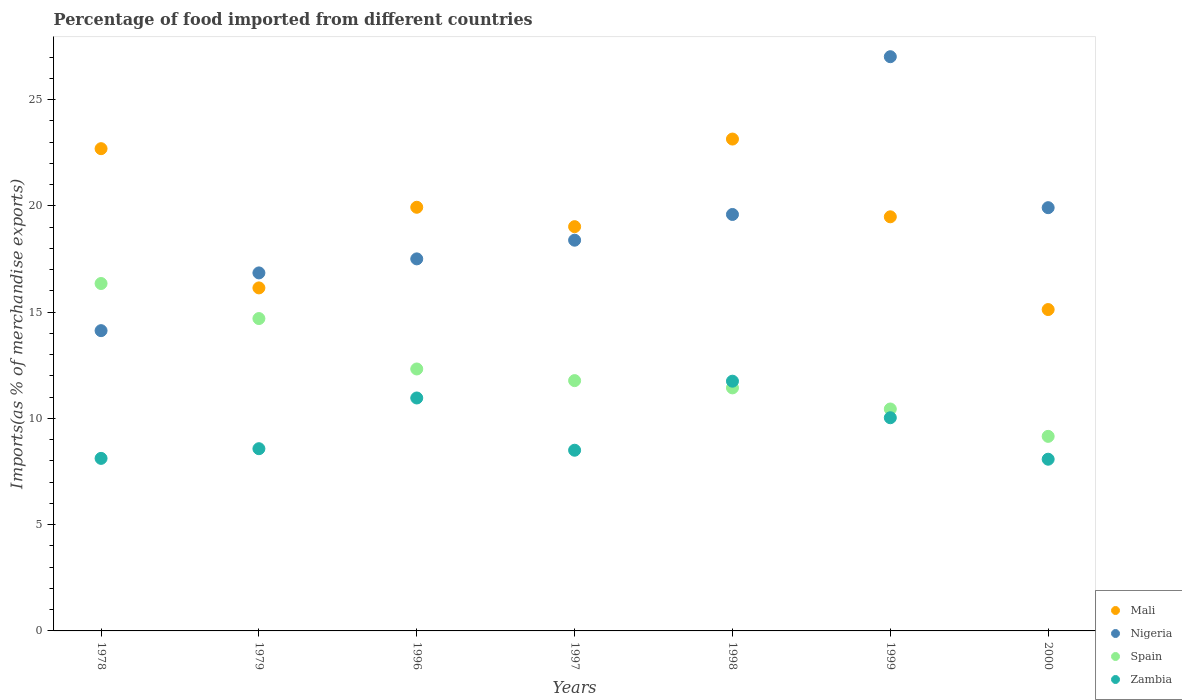How many different coloured dotlines are there?
Your answer should be very brief. 4. Is the number of dotlines equal to the number of legend labels?
Provide a succinct answer. Yes. What is the percentage of imports to different countries in Mali in 2000?
Keep it short and to the point. 15.12. Across all years, what is the maximum percentage of imports to different countries in Zambia?
Make the answer very short. 11.75. Across all years, what is the minimum percentage of imports to different countries in Nigeria?
Your answer should be very brief. 14.13. In which year was the percentage of imports to different countries in Mali maximum?
Make the answer very short. 1998. In which year was the percentage of imports to different countries in Nigeria minimum?
Your response must be concise. 1978. What is the total percentage of imports to different countries in Nigeria in the graph?
Offer a very short reply. 133.41. What is the difference between the percentage of imports to different countries in Zambia in 1979 and that in 1996?
Offer a very short reply. -2.39. What is the difference between the percentage of imports to different countries in Spain in 1979 and the percentage of imports to different countries in Mali in 1997?
Keep it short and to the point. -4.32. What is the average percentage of imports to different countries in Mali per year?
Provide a succinct answer. 19.36. In the year 1979, what is the difference between the percentage of imports to different countries in Spain and percentage of imports to different countries in Zambia?
Your answer should be compact. 6.12. In how many years, is the percentage of imports to different countries in Mali greater than 24 %?
Your response must be concise. 0. What is the ratio of the percentage of imports to different countries in Nigeria in 1996 to that in 2000?
Offer a terse response. 0.88. Is the percentage of imports to different countries in Mali in 1978 less than that in 1979?
Offer a very short reply. No. What is the difference between the highest and the second highest percentage of imports to different countries in Spain?
Ensure brevity in your answer.  1.65. What is the difference between the highest and the lowest percentage of imports to different countries in Nigeria?
Your response must be concise. 12.89. In how many years, is the percentage of imports to different countries in Zambia greater than the average percentage of imports to different countries in Zambia taken over all years?
Provide a short and direct response. 3. Is it the case that in every year, the sum of the percentage of imports to different countries in Nigeria and percentage of imports to different countries in Mali  is greater than the sum of percentage of imports to different countries in Spain and percentage of imports to different countries in Zambia?
Ensure brevity in your answer.  Yes. Is it the case that in every year, the sum of the percentage of imports to different countries in Zambia and percentage of imports to different countries in Nigeria  is greater than the percentage of imports to different countries in Mali?
Ensure brevity in your answer.  No. How many dotlines are there?
Offer a very short reply. 4. How many years are there in the graph?
Your response must be concise. 7. What is the difference between two consecutive major ticks on the Y-axis?
Your response must be concise. 5. Are the values on the major ticks of Y-axis written in scientific E-notation?
Your answer should be very brief. No. Does the graph contain any zero values?
Your answer should be very brief. No. Does the graph contain grids?
Give a very brief answer. No. Where does the legend appear in the graph?
Make the answer very short. Bottom right. How are the legend labels stacked?
Offer a terse response. Vertical. What is the title of the graph?
Provide a succinct answer. Percentage of food imported from different countries. Does "St. Kitts and Nevis" appear as one of the legend labels in the graph?
Make the answer very short. No. What is the label or title of the Y-axis?
Ensure brevity in your answer.  Imports(as % of merchandise exports). What is the Imports(as % of merchandise exports) in Mali in 1978?
Offer a terse response. 22.69. What is the Imports(as % of merchandise exports) of Nigeria in 1978?
Ensure brevity in your answer.  14.13. What is the Imports(as % of merchandise exports) of Spain in 1978?
Keep it short and to the point. 16.35. What is the Imports(as % of merchandise exports) of Zambia in 1978?
Provide a succinct answer. 8.12. What is the Imports(as % of merchandise exports) in Mali in 1979?
Offer a terse response. 16.14. What is the Imports(as % of merchandise exports) of Nigeria in 1979?
Offer a terse response. 16.85. What is the Imports(as % of merchandise exports) of Spain in 1979?
Keep it short and to the point. 14.7. What is the Imports(as % of merchandise exports) in Zambia in 1979?
Offer a terse response. 8.57. What is the Imports(as % of merchandise exports) in Mali in 1996?
Make the answer very short. 19.94. What is the Imports(as % of merchandise exports) in Nigeria in 1996?
Keep it short and to the point. 17.51. What is the Imports(as % of merchandise exports) in Spain in 1996?
Your answer should be compact. 12.33. What is the Imports(as % of merchandise exports) in Zambia in 1996?
Ensure brevity in your answer.  10.96. What is the Imports(as % of merchandise exports) in Mali in 1997?
Offer a very short reply. 19.02. What is the Imports(as % of merchandise exports) of Nigeria in 1997?
Provide a short and direct response. 18.39. What is the Imports(as % of merchandise exports) of Spain in 1997?
Your response must be concise. 11.78. What is the Imports(as % of merchandise exports) in Zambia in 1997?
Give a very brief answer. 8.5. What is the Imports(as % of merchandise exports) of Mali in 1998?
Offer a terse response. 23.15. What is the Imports(as % of merchandise exports) in Nigeria in 1998?
Offer a very short reply. 19.6. What is the Imports(as % of merchandise exports) of Spain in 1998?
Offer a very short reply. 11.44. What is the Imports(as % of merchandise exports) in Zambia in 1998?
Provide a short and direct response. 11.75. What is the Imports(as % of merchandise exports) in Mali in 1999?
Keep it short and to the point. 19.49. What is the Imports(as % of merchandise exports) in Nigeria in 1999?
Give a very brief answer. 27.02. What is the Imports(as % of merchandise exports) of Spain in 1999?
Your answer should be compact. 10.44. What is the Imports(as % of merchandise exports) in Zambia in 1999?
Make the answer very short. 10.03. What is the Imports(as % of merchandise exports) of Mali in 2000?
Your response must be concise. 15.12. What is the Imports(as % of merchandise exports) in Nigeria in 2000?
Offer a very short reply. 19.92. What is the Imports(as % of merchandise exports) in Spain in 2000?
Make the answer very short. 9.16. What is the Imports(as % of merchandise exports) of Zambia in 2000?
Provide a short and direct response. 8.08. Across all years, what is the maximum Imports(as % of merchandise exports) of Mali?
Ensure brevity in your answer.  23.15. Across all years, what is the maximum Imports(as % of merchandise exports) of Nigeria?
Give a very brief answer. 27.02. Across all years, what is the maximum Imports(as % of merchandise exports) of Spain?
Offer a terse response. 16.35. Across all years, what is the maximum Imports(as % of merchandise exports) of Zambia?
Your answer should be compact. 11.75. Across all years, what is the minimum Imports(as % of merchandise exports) in Mali?
Your response must be concise. 15.12. Across all years, what is the minimum Imports(as % of merchandise exports) in Nigeria?
Ensure brevity in your answer.  14.13. Across all years, what is the minimum Imports(as % of merchandise exports) in Spain?
Make the answer very short. 9.16. Across all years, what is the minimum Imports(as % of merchandise exports) of Zambia?
Offer a terse response. 8.08. What is the total Imports(as % of merchandise exports) of Mali in the graph?
Provide a succinct answer. 135.55. What is the total Imports(as % of merchandise exports) in Nigeria in the graph?
Your answer should be very brief. 133.41. What is the total Imports(as % of merchandise exports) in Spain in the graph?
Provide a succinct answer. 86.19. What is the total Imports(as % of merchandise exports) in Zambia in the graph?
Your response must be concise. 66.02. What is the difference between the Imports(as % of merchandise exports) of Mali in 1978 and that in 1979?
Your response must be concise. 6.55. What is the difference between the Imports(as % of merchandise exports) in Nigeria in 1978 and that in 1979?
Provide a succinct answer. -2.72. What is the difference between the Imports(as % of merchandise exports) in Spain in 1978 and that in 1979?
Ensure brevity in your answer.  1.65. What is the difference between the Imports(as % of merchandise exports) in Zambia in 1978 and that in 1979?
Ensure brevity in your answer.  -0.46. What is the difference between the Imports(as % of merchandise exports) in Mali in 1978 and that in 1996?
Offer a terse response. 2.76. What is the difference between the Imports(as % of merchandise exports) of Nigeria in 1978 and that in 1996?
Give a very brief answer. -3.38. What is the difference between the Imports(as % of merchandise exports) in Spain in 1978 and that in 1996?
Provide a short and direct response. 4.02. What is the difference between the Imports(as % of merchandise exports) of Zambia in 1978 and that in 1996?
Give a very brief answer. -2.84. What is the difference between the Imports(as % of merchandise exports) of Mali in 1978 and that in 1997?
Your answer should be very brief. 3.67. What is the difference between the Imports(as % of merchandise exports) in Nigeria in 1978 and that in 1997?
Provide a succinct answer. -4.26. What is the difference between the Imports(as % of merchandise exports) in Spain in 1978 and that in 1997?
Your answer should be very brief. 4.57. What is the difference between the Imports(as % of merchandise exports) of Zambia in 1978 and that in 1997?
Give a very brief answer. -0.38. What is the difference between the Imports(as % of merchandise exports) in Mali in 1978 and that in 1998?
Provide a succinct answer. -0.45. What is the difference between the Imports(as % of merchandise exports) in Nigeria in 1978 and that in 1998?
Ensure brevity in your answer.  -5.47. What is the difference between the Imports(as % of merchandise exports) in Spain in 1978 and that in 1998?
Provide a succinct answer. 4.91. What is the difference between the Imports(as % of merchandise exports) in Zambia in 1978 and that in 1998?
Provide a short and direct response. -3.63. What is the difference between the Imports(as % of merchandise exports) in Mali in 1978 and that in 1999?
Provide a short and direct response. 3.21. What is the difference between the Imports(as % of merchandise exports) of Nigeria in 1978 and that in 1999?
Your response must be concise. -12.89. What is the difference between the Imports(as % of merchandise exports) in Spain in 1978 and that in 1999?
Provide a short and direct response. 5.91. What is the difference between the Imports(as % of merchandise exports) in Zambia in 1978 and that in 1999?
Your response must be concise. -1.91. What is the difference between the Imports(as % of merchandise exports) of Mali in 1978 and that in 2000?
Give a very brief answer. 7.57. What is the difference between the Imports(as % of merchandise exports) in Nigeria in 1978 and that in 2000?
Keep it short and to the point. -5.79. What is the difference between the Imports(as % of merchandise exports) of Spain in 1978 and that in 2000?
Provide a short and direct response. 7.19. What is the difference between the Imports(as % of merchandise exports) in Zambia in 1978 and that in 2000?
Keep it short and to the point. 0.04. What is the difference between the Imports(as % of merchandise exports) of Mali in 1979 and that in 1996?
Your response must be concise. -3.79. What is the difference between the Imports(as % of merchandise exports) of Nigeria in 1979 and that in 1996?
Your answer should be compact. -0.66. What is the difference between the Imports(as % of merchandise exports) of Spain in 1979 and that in 1996?
Your answer should be compact. 2.37. What is the difference between the Imports(as % of merchandise exports) in Zambia in 1979 and that in 1996?
Ensure brevity in your answer.  -2.39. What is the difference between the Imports(as % of merchandise exports) of Mali in 1979 and that in 1997?
Provide a short and direct response. -2.88. What is the difference between the Imports(as % of merchandise exports) in Nigeria in 1979 and that in 1997?
Offer a terse response. -1.54. What is the difference between the Imports(as % of merchandise exports) of Spain in 1979 and that in 1997?
Your answer should be compact. 2.92. What is the difference between the Imports(as % of merchandise exports) of Zambia in 1979 and that in 1997?
Your response must be concise. 0.07. What is the difference between the Imports(as % of merchandise exports) in Mali in 1979 and that in 1998?
Provide a short and direct response. -7. What is the difference between the Imports(as % of merchandise exports) in Nigeria in 1979 and that in 1998?
Your answer should be compact. -2.75. What is the difference between the Imports(as % of merchandise exports) in Spain in 1979 and that in 1998?
Your response must be concise. 3.26. What is the difference between the Imports(as % of merchandise exports) in Zambia in 1979 and that in 1998?
Provide a short and direct response. -3.18. What is the difference between the Imports(as % of merchandise exports) of Mali in 1979 and that in 1999?
Offer a terse response. -3.35. What is the difference between the Imports(as % of merchandise exports) of Nigeria in 1979 and that in 1999?
Keep it short and to the point. -10.17. What is the difference between the Imports(as % of merchandise exports) of Spain in 1979 and that in 1999?
Give a very brief answer. 4.26. What is the difference between the Imports(as % of merchandise exports) of Zambia in 1979 and that in 1999?
Your answer should be compact. -1.46. What is the difference between the Imports(as % of merchandise exports) of Mali in 1979 and that in 2000?
Give a very brief answer. 1.02. What is the difference between the Imports(as % of merchandise exports) in Nigeria in 1979 and that in 2000?
Keep it short and to the point. -3.07. What is the difference between the Imports(as % of merchandise exports) in Spain in 1979 and that in 2000?
Provide a short and direct response. 5.54. What is the difference between the Imports(as % of merchandise exports) in Zambia in 1979 and that in 2000?
Make the answer very short. 0.49. What is the difference between the Imports(as % of merchandise exports) in Mali in 1996 and that in 1997?
Make the answer very short. 0.91. What is the difference between the Imports(as % of merchandise exports) of Nigeria in 1996 and that in 1997?
Your response must be concise. -0.88. What is the difference between the Imports(as % of merchandise exports) of Spain in 1996 and that in 1997?
Your answer should be compact. 0.55. What is the difference between the Imports(as % of merchandise exports) in Zambia in 1996 and that in 1997?
Make the answer very short. 2.46. What is the difference between the Imports(as % of merchandise exports) of Mali in 1996 and that in 1998?
Keep it short and to the point. -3.21. What is the difference between the Imports(as % of merchandise exports) of Nigeria in 1996 and that in 1998?
Give a very brief answer. -2.09. What is the difference between the Imports(as % of merchandise exports) in Spain in 1996 and that in 1998?
Your response must be concise. 0.89. What is the difference between the Imports(as % of merchandise exports) in Zambia in 1996 and that in 1998?
Give a very brief answer. -0.79. What is the difference between the Imports(as % of merchandise exports) in Mali in 1996 and that in 1999?
Your answer should be very brief. 0.45. What is the difference between the Imports(as % of merchandise exports) of Nigeria in 1996 and that in 1999?
Offer a very short reply. -9.51. What is the difference between the Imports(as % of merchandise exports) in Spain in 1996 and that in 1999?
Offer a terse response. 1.88. What is the difference between the Imports(as % of merchandise exports) in Zambia in 1996 and that in 1999?
Keep it short and to the point. 0.93. What is the difference between the Imports(as % of merchandise exports) in Mali in 1996 and that in 2000?
Provide a short and direct response. 4.81. What is the difference between the Imports(as % of merchandise exports) in Nigeria in 1996 and that in 2000?
Give a very brief answer. -2.41. What is the difference between the Imports(as % of merchandise exports) in Spain in 1996 and that in 2000?
Your answer should be very brief. 3.17. What is the difference between the Imports(as % of merchandise exports) of Zambia in 1996 and that in 2000?
Give a very brief answer. 2.88. What is the difference between the Imports(as % of merchandise exports) in Mali in 1997 and that in 1998?
Ensure brevity in your answer.  -4.12. What is the difference between the Imports(as % of merchandise exports) of Nigeria in 1997 and that in 1998?
Your answer should be compact. -1.21. What is the difference between the Imports(as % of merchandise exports) in Spain in 1997 and that in 1998?
Offer a terse response. 0.34. What is the difference between the Imports(as % of merchandise exports) in Zambia in 1997 and that in 1998?
Ensure brevity in your answer.  -3.25. What is the difference between the Imports(as % of merchandise exports) of Mali in 1997 and that in 1999?
Ensure brevity in your answer.  -0.46. What is the difference between the Imports(as % of merchandise exports) in Nigeria in 1997 and that in 1999?
Provide a short and direct response. -8.63. What is the difference between the Imports(as % of merchandise exports) of Spain in 1997 and that in 1999?
Provide a succinct answer. 1.34. What is the difference between the Imports(as % of merchandise exports) of Zambia in 1997 and that in 1999?
Keep it short and to the point. -1.53. What is the difference between the Imports(as % of merchandise exports) of Mali in 1997 and that in 2000?
Your answer should be compact. 3.9. What is the difference between the Imports(as % of merchandise exports) in Nigeria in 1997 and that in 2000?
Provide a succinct answer. -1.53. What is the difference between the Imports(as % of merchandise exports) in Spain in 1997 and that in 2000?
Give a very brief answer. 2.62. What is the difference between the Imports(as % of merchandise exports) in Zambia in 1997 and that in 2000?
Offer a very short reply. 0.42. What is the difference between the Imports(as % of merchandise exports) of Mali in 1998 and that in 1999?
Offer a very short reply. 3.66. What is the difference between the Imports(as % of merchandise exports) in Nigeria in 1998 and that in 1999?
Make the answer very short. -7.42. What is the difference between the Imports(as % of merchandise exports) in Zambia in 1998 and that in 1999?
Offer a terse response. 1.72. What is the difference between the Imports(as % of merchandise exports) in Mali in 1998 and that in 2000?
Your response must be concise. 8.02. What is the difference between the Imports(as % of merchandise exports) in Nigeria in 1998 and that in 2000?
Give a very brief answer. -0.32. What is the difference between the Imports(as % of merchandise exports) in Spain in 1998 and that in 2000?
Offer a very short reply. 2.28. What is the difference between the Imports(as % of merchandise exports) in Zambia in 1998 and that in 2000?
Make the answer very short. 3.67. What is the difference between the Imports(as % of merchandise exports) of Mali in 1999 and that in 2000?
Give a very brief answer. 4.36. What is the difference between the Imports(as % of merchandise exports) of Nigeria in 1999 and that in 2000?
Provide a short and direct response. 7.1. What is the difference between the Imports(as % of merchandise exports) of Spain in 1999 and that in 2000?
Offer a terse response. 1.29. What is the difference between the Imports(as % of merchandise exports) in Zambia in 1999 and that in 2000?
Offer a very short reply. 1.95. What is the difference between the Imports(as % of merchandise exports) in Mali in 1978 and the Imports(as % of merchandise exports) in Nigeria in 1979?
Your response must be concise. 5.85. What is the difference between the Imports(as % of merchandise exports) in Mali in 1978 and the Imports(as % of merchandise exports) in Spain in 1979?
Keep it short and to the point. 7.99. What is the difference between the Imports(as % of merchandise exports) in Mali in 1978 and the Imports(as % of merchandise exports) in Zambia in 1979?
Make the answer very short. 14.12. What is the difference between the Imports(as % of merchandise exports) in Nigeria in 1978 and the Imports(as % of merchandise exports) in Spain in 1979?
Offer a very short reply. -0.57. What is the difference between the Imports(as % of merchandise exports) of Nigeria in 1978 and the Imports(as % of merchandise exports) of Zambia in 1979?
Your answer should be compact. 5.55. What is the difference between the Imports(as % of merchandise exports) of Spain in 1978 and the Imports(as % of merchandise exports) of Zambia in 1979?
Your answer should be compact. 7.77. What is the difference between the Imports(as % of merchandise exports) of Mali in 1978 and the Imports(as % of merchandise exports) of Nigeria in 1996?
Give a very brief answer. 5.19. What is the difference between the Imports(as % of merchandise exports) of Mali in 1978 and the Imports(as % of merchandise exports) of Spain in 1996?
Provide a succinct answer. 10.37. What is the difference between the Imports(as % of merchandise exports) of Mali in 1978 and the Imports(as % of merchandise exports) of Zambia in 1996?
Provide a succinct answer. 11.73. What is the difference between the Imports(as % of merchandise exports) in Nigeria in 1978 and the Imports(as % of merchandise exports) in Spain in 1996?
Give a very brief answer. 1.8. What is the difference between the Imports(as % of merchandise exports) in Nigeria in 1978 and the Imports(as % of merchandise exports) in Zambia in 1996?
Make the answer very short. 3.17. What is the difference between the Imports(as % of merchandise exports) of Spain in 1978 and the Imports(as % of merchandise exports) of Zambia in 1996?
Offer a terse response. 5.39. What is the difference between the Imports(as % of merchandise exports) of Mali in 1978 and the Imports(as % of merchandise exports) of Nigeria in 1997?
Your answer should be very brief. 4.31. What is the difference between the Imports(as % of merchandise exports) of Mali in 1978 and the Imports(as % of merchandise exports) of Spain in 1997?
Your answer should be compact. 10.91. What is the difference between the Imports(as % of merchandise exports) in Mali in 1978 and the Imports(as % of merchandise exports) in Zambia in 1997?
Your response must be concise. 14.19. What is the difference between the Imports(as % of merchandise exports) in Nigeria in 1978 and the Imports(as % of merchandise exports) in Spain in 1997?
Offer a very short reply. 2.35. What is the difference between the Imports(as % of merchandise exports) in Nigeria in 1978 and the Imports(as % of merchandise exports) in Zambia in 1997?
Provide a short and direct response. 5.63. What is the difference between the Imports(as % of merchandise exports) of Spain in 1978 and the Imports(as % of merchandise exports) of Zambia in 1997?
Make the answer very short. 7.85. What is the difference between the Imports(as % of merchandise exports) of Mali in 1978 and the Imports(as % of merchandise exports) of Nigeria in 1998?
Your response must be concise. 3.1. What is the difference between the Imports(as % of merchandise exports) in Mali in 1978 and the Imports(as % of merchandise exports) in Spain in 1998?
Your response must be concise. 11.26. What is the difference between the Imports(as % of merchandise exports) in Mali in 1978 and the Imports(as % of merchandise exports) in Zambia in 1998?
Offer a terse response. 10.94. What is the difference between the Imports(as % of merchandise exports) in Nigeria in 1978 and the Imports(as % of merchandise exports) in Spain in 1998?
Your answer should be compact. 2.69. What is the difference between the Imports(as % of merchandise exports) of Nigeria in 1978 and the Imports(as % of merchandise exports) of Zambia in 1998?
Make the answer very short. 2.38. What is the difference between the Imports(as % of merchandise exports) of Spain in 1978 and the Imports(as % of merchandise exports) of Zambia in 1998?
Provide a short and direct response. 4.6. What is the difference between the Imports(as % of merchandise exports) in Mali in 1978 and the Imports(as % of merchandise exports) in Nigeria in 1999?
Make the answer very short. -4.33. What is the difference between the Imports(as % of merchandise exports) in Mali in 1978 and the Imports(as % of merchandise exports) in Spain in 1999?
Keep it short and to the point. 12.25. What is the difference between the Imports(as % of merchandise exports) of Mali in 1978 and the Imports(as % of merchandise exports) of Zambia in 1999?
Make the answer very short. 12.66. What is the difference between the Imports(as % of merchandise exports) of Nigeria in 1978 and the Imports(as % of merchandise exports) of Spain in 1999?
Your answer should be compact. 3.69. What is the difference between the Imports(as % of merchandise exports) in Nigeria in 1978 and the Imports(as % of merchandise exports) in Zambia in 1999?
Keep it short and to the point. 4.1. What is the difference between the Imports(as % of merchandise exports) in Spain in 1978 and the Imports(as % of merchandise exports) in Zambia in 1999?
Provide a succinct answer. 6.32. What is the difference between the Imports(as % of merchandise exports) of Mali in 1978 and the Imports(as % of merchandise exports) of Nigeria in 2000?
Keep it short and to the point. 2.78. What is the difference between the Imports(as % of merchandise exports) of Mali in 1978 and the Imports(as % of merchandise exports) of Spain in 2000?
Your answer should be compact. 13.54. What is the difference between the Imports(as % of merchandise exports) in Mali in 1978 and the Imports(as % of merchandise exports) in Zambia in 2000?
Your answer should be compact. 14.61. What is the difference between the Imports(as % of merchandise exports) in Nigeria in 1978 and the Imports(as % of merchandise exports) in Spain in 2000?
Provide a succinct answer. 4.97. What is the difference between the Imports(as % of merchandise exports) in Nigeria in 1978 and the Imports(as % of merchandise exports) in Zambia in 2000?
Keep it short and to the point. 6.05. What is the difference between the Imports(as % of merchandise exports) in Spain in 1978 and the Imports(as % of merchandise exports) in Zambia in 2000?
Keep it short and to the point. 8.27. What is the difference between the Imports(as % of merchandise exports) in Mali in 1979 and the Imports(as % of merchandise exports) in Nigeria in 1996?
Keep it short and to the point. -1.37. What is the difference between the Imports(as % of merchandise exports) of Mali in 1979 and the Imports(as % of merchandise exports) of Spain in 1996?
Provide a short and direct response. 3.82. What is the difference between the Imports(as % of merchandise exports) in Mali in 1979 and the Imports(as % of merchandise exports) in Zambia in 1996?
Offer a very short reply. 5.18. What is the difference between the Imports(as % of merchandise exports) in Nigeria in 1979 and the Imports(as % of merchandise exports) in Spain in 1996?
Keep it short and to the point. 4.52. What is the difference between the Imports(as % of merchandise exports) in Nigeria in 1979 and the Imports(as % of merchandise exports) in Zambia in 1996?
Provide a succinct answer. 5.89. What is the difference between the Imports(as % of merchandise exports) of Spain in 1979 and the Imports(as % of merchandise exports) of Zambia in 1996?
Your answer should be compact. 3.74. What is the difference between the Imports(as % of merchandise exports) in Mali in 1979 and the Imports(as % of merchandise exports) in Nigeria in 1997?
Ensure brevity in your answer.  -2.25. What is the difference between the Imports(as % of merchandise exports) in Mali in 1979 and the Imports(as % of merchandise exports) in Spain in 1997?
Provide a short and direct response. 4.36. What is the difference between the Imports(as % of merchandise exports) of Mali in 1979 and the Imports(as % of merchandise exports) of Zambia in 1997?
Your response must be concise. 7.64. What is the difference between the Imports(as % of merchandise exports) of Nigeria in 1979 and the Imports(as % of merchandise exports) of Spain in 1997?
Make the answer very short. 5.07. What is the difference between the Imports(as % of merchandise exports) in Nigeria in 1979 and the Imports(as % of merchandise exports) in Zambia in 1997?
Provide a succinct answer. 8.34. What is the difference between the Imports(as % of merchandise exports) of Spain in 1979 and the Imports(as % of merchandise exports) of Zambia in 1997?
Offer a very short reply. 6.2. What is the difference between the Imports(as % of merchandise exports) in Mali in 1979 and the Imports(as % of merchandise exports) in Nigeria in 1998?
Your answer should be compact. -3.46. What is the difference between the Imports(as % of merchandise exports) of Mali in 1979 and the Imports(as % of merchandise exports) of Spain in 1998?
Give a very brief answer. 4.7. What is the difference between the Imports(as % of merchandise exports) of Mali in 1979 and the Imports(as % of merchandise exports) of Zambia in 1998?
Give a very brief answer. 4.39. What is the difference between the Imports(as % of merchandise exports) of Nigeria in 1979 and the Imports(as % of merchandise exports) of Spain in 1998?
Offer a terse response. 5.41. What is the difference between the Imports(as % of merchandise exports) in Nigeria in 1979 and the Imports(as % of merchandise exports) in Zambia in 1998?
Offer a terse response. 5.1. What is the difference between the Imports(as % of merchandise exports) in Spain in 1979 and the Imports(as % of merchandise exports) in Zambia in 1998?
Keep it short and to the point. 2.95. What is the difference between the Imports(as % of merchandise exports) of Mali in 1979 and the Imports(as % of merchandise exports) of Nigeria in 1999?
Provide a short and direct response. -10.88. What is the difference between the Imports(as % of merchandise exports) of Mali in 1979 and the Imports(as % of merchandise exports) of Spain in 1999?
Your answer should be very brief. 5.7. What is the difference between the Imports(as % of merchandise exports) in Mali in 1979 and the Imports(as % of merchandise exports) in Zambia in 1999?
Your answer should be very brief. 6.11. What is the difference between the Imports(as % of merchandise exports) in Nigeria in 1979 and the Imports(as % of merchandise exports) in Spain in 1999?
Provide a short and direct response. 6.4. What is the difference between the Imports(as % of merchandise exports) of Nigeria in 1979 and the Imports(as % of merchandise exports) of Zambia in 1999?
Offer a terse response. 6.82. What is the difference between the Imports(as % of merchandise exports) in Spain in 1979 and the Imports(as % of merchandise exports) in Zambia in 1999?
Provide a short and direct response. 4.67. What is the difference between the Imports(as % of merchandise exports) of Mali in 1979 and the Imports(as % of merchandise exports) of Nigeria in 2000?
Offer a very short reply. -3.78. What is the difference between the Imports(as % of merchandise exports) of Mali in 1979 and the Imports(as % of merchandise exports) of Spain in 2000?
Offer a terse response. 6.99. What is the difference between the Imports(as % of merchandise exports) of Mali in 1979 and the Imports(as % of merchandise exports) of Zambia in 2000?
Your answer should be very brief. 8.06. What is the difference between the Imports(as % of merchandise exports) of Nigeria in 1979 and the Imports(as % of merchandise exports) of Spain in 2000?
Provide a short and direct response. 7.69. What is the difference between the Imports(as % of merchandise exports) in Nigeria in 1979 and the Imports(as % of merchandise exports) in Zambia in 2000?
Ensure brevity in your answer.  8.77. What is the difference between the Imports(as % of merchandise exports) of Spain in 1979 and the Imports(as % of merchandise exports) of Zambia in 2000?
Provide a succinct answer. 6.62. What is the difference between the Imports(as % of merchandise exports) of Mali in 1996 and the Imports(as % of merchandise exports) of Nigeria in 1997?
Give a very brief answer. 1.55. What is the difference between the Imports(as % of merchandise exports) of Mali in 1996 and the Imports(as % of merchandise exports) of Spain in 1997?
Offer a terse response. 8.16. What is the difference between the Imports(as % of merchandise exports) in Mali in 1996 and the Imports(as % of merchandise exports) in Zambia in 1997?
Your response must be concise. 11.43. What is the difference between the Imports(as % of merchandise exports) in Nigeria in 1996 and the Imports(as % of merchandise exports) in Spain in 1997?
Your answer should be compact. 5.73. What is the difference between the Imports(as % of merchandise exports) of Nigeria in 1996 and the Imports(as % of merchandise exports) of Zambia in 1997?
Provide a succinct answer. 9. What is the difference between the Imports(as % of merchandise exports) of Spain in 1996 and the Imports(as % of merchandise exports) of Zambia in 1997?
Your response must be concise. 3.82. What is the difference between the Imports(as % of merchandise exports) of Mali in 1996 and the Imports(as % of merchandise exports) of Nigeria in 1998?
Ensure brevity in your answer.  0.34. What is the difference between the Imports(as % of merchandise exports) of Mali in 1996 and the Imports(as % of merchandise exports) of Spain in 1998?
Your answer should be very brief. 8.5. What is the difference between the Imports(as % of merchandise exports) of Mali in 1996 and the Imports(as % of merchandise exports) of Zambia in 1998?
Provide a succinct answer. 8.18. What is the difference between the Imports(as % of merchandise exports) of Nigeria in 1996 and the Imports(as % of merchandise exports) of Spain in 1998?
Provide a short and direct response. 6.07. What is the difference between the Imports(as % of merchandise exports) of Nigeria in 1996 and the Imports(as % of merchandise exports) of Zambia in 1998?
Your answer should be compact. 5.76. What is the difference between the Imports(as % of merchandise exports) in Spain in 1996 and the Imports(as % of merchandise exports) in Zambia in 1998?
Give a very brief answer. 0.57. What is the difference between the Imports(as % of merchandise exports) in Mali in 1996 and the Imports(as % of merchandise exports) in Nigeria in 1999?
Make the answer very short. -7.09. What is the difference between the Imports(as % of merchandise exports) in Mali in 1996 and the Imports(as % of merchandise exports) in Spain in 1999?
Offer a terse response. 9.49. What is the difference between the Imports(as % of merchandise exports) in Mali in 1996 and the Imports(as % of merchandise exports) in Zambia in 1999?
Your response must be concise. 9.9. What is the difference between the Imports(as % of merchandise exports) of Nigeria in 1996 and the Imports(as % of merchandise exports) of Spain in 1999?
Give a very brief answer. 7.06. What is the difference between the Imports(as % of merchandise exports) in Nigeria in 1996 and the Imports(as % of merchandise exports) in Zambia in 1999?
Your response must be concise. 7.48. What is the difference between the Imports(as % of merchandise exports) in Spain in 1996 and the Imports(as % of merchandise exports) in Zambia in 1999?
Offer a terse response. 2.29. What is the difference between the Imports(as % of merchandise exports) in Mali in 1996 and the Imports(as % of merchandise exports) in Nigeria in 2000?
Offer a terse response. 0.02. What is the difference between the Imports(as % of merchandise exports) of Mali in 1996 and the Imports(as % of merchandise exports) of Spain in 2000?
Ensure brevity in your answer.  10.78. What is the difference between the Imports(as % of merchandise exports) of Mali in 1996 and the Imports(as % of merchandise exports) of Zambia in 2000?
Your answer should be compact. 11.86. What is the difference between the Imports(as % of merchandise exports) of Nigeria in 1996 and the Imports(as % of merchandise exports) of Spain in 2000?
Keep it short and to the point. 8.35. What is the difference between the Imports(as % of merchandise exports) in Nigeria in 1996 and the Imports(as % of merchandise exports) in Zambia in 2000?
Your answer should be very brief. 9.43. What is the difference between the Imports(as % of merchandise exports) of Spain in 1996 and the Imports(as % of merchandise exports) of Zambia in 2000?
Your response must be concise. 4.25. What is the difference between the Imports(as % of merchandise exports) in Mali in 1997 and the Imports(as % of merchandise exports) in Nigeria in 1998?
Make the answer very short. -0.57. What is the difference between the Imports(as % of merchandise exports) in Mali in 1997 and the Imports(as % of merchandise exports) in Spain in 1998?
Provide a succinct answer. 7.59. What is the difference between the Imports(as % of merchandise exports) in Mali in 1997 and the Imports(as % of merchandise exports) in Zambia in 1998?
Make the answer very short. 7.27. What is the difference between the Imports(as % of merchandise exports) of Nigeria in 1997 and the Imports(as % of merchandise exports) of Spain in 1998?
Make the answer very short. 6.95. What is the difference between the Imports(as % of merchandise exports) of Nigeria in 1997 and the Imports(as % of merchandise exports) of Zambia in 1998?
Make the answer very short. 6.63. What is the difference between the Imports(as % of merchandise exports) of Spain in 1997 and the Imports(as % of merchandise exports) of Zambia in 1998?
Your response must be concise. 0.03. What is the difference between the Imports(as % of merchandise exports) in Mali in 1997 and the Imports(as % of merchandise exports) in Nigeria in 1999?
Ensure brevity in your answer.  -8. What is the difference between the Imports(as % of merchandise exports) in Mali in 1997 and the Imports(as % of merchandise exports) in Spain in 1999?
Ensure brevity in your answer.  8.58. What is the difference between the Imports(as % of merchandise exports) of Mali in 1997 and the Imports(as % of merchandise exports) of Zambia in 1999?
Your answer should be very brief. 8.99. What is the difference between the Imports(as % of merchandise exports) of Nigeria in 1997 and the Imports(as % of merchandise exports) of Spain in 1999?
Your response must be concise. 7.94. What is the difference between the Imports(as % of merchandise exports) in Nigeria in 1997 and the Imports(as % of merchandise exports) in Zambia in 1999?
Make the answer very short. 8.35. What is the difference between the Imports(as % of merchandise exports) in Spain in 1997 and the Imports(as % of merchandise exports) in Zambia in 1999?
Provide a succinct answer. 1.75. What is the difference between the Imports(as % of merchandise exports) of Mali in 1997 and the Imports(as % of merchandise exports) of Nigeria in 2000?
Offer a very short reply. -0.89. What is the difference between the Imports(as % of merchandise exports) of Mali in 1997 and the Imports(as % of merchandise exports) of Spain in 2000?
Your answer should be very brief. 9.87. What is the difference between the Imports(as % of merchandise exports) of Mali in 1997 and the Imports(as % of merchandise exports) of Zambia in 2000?
Provide a succinct answer. 10.94. What is the difference between the Imports(as % of merchandise exports) in Nigeria in 1997 and the Imports(as % of merchandise exports) in Spain in 2000?
Ensure brevity in your answer.  9.23. What is the difference between the Imports(as % of merchandise exports) in Nigeria in 1997 and the Imports(as % of merchandise exports) in Zambia in 2000?
Your response must be concise. 10.31. What is the difference between the Imports(as % of merchandise exports) of Spain in 1997 and the Imports(as % of merchandise exports) of Zambia in 2000?
Make the answer very short. 3.7. What is the difference between the Imports(as % of merchandise exports) in Mali in 1998 and the Imports(as % of merchandise exports) in Nigeria in 1999?
Your answer should be compact. -3.88. What is the difference between the Imports(as % of merchandise exports) in Mali in 1998 and the Imports(as % of merchandise exports) in Spain in 1999?
Provide a short and direct response. 12.7. What is the difference between the Imports(as % of merchandise exports) in Mali in 1998 and the Imports(as % of merchandise exports) in Zambia in 1999?
Offer a terse response. 13.11. What is the difference between the Imports(as % of merchandise exports) in Nigeria in 1998 and the Imports(as % of merchandise exports) in Spain in 1999?
Provide a succinct answer. 9.15. What is the difference between the Imports(as % of merchandise exports) of Nigeria in 1998 and the Imports(as % of merchandise exports) of Zambia in 1999?
Your response must be concise. 9.57. What is the difference between the Imports(as % of merchandise exports) in Spain in 1998 and the Imports(as % of merchandise exports) in Zambia in 1999?
Provide a short and direct response. 1.4. What is the difference between the Imports(as % of merchandise exports) in Mali in 1998 and the Imports(as % of merchandise exports) in Nigeria in 2000?
Provide a succinct answer. 3.23. What is the difference between the Imports(as % of merchandise exports) of Mali in 1998 and the Imports(as % of merchandise exports) of Spain in 2000?
Your answer should be very brief. 13.99. What is the difference between the Imports(as % of merchandise exports) in Mali in 1998 and the Imports(as % of merchandise exports) in Zambia in 2000?
Ensure brevity in your answer.  15.07. What is the difference between the Imports(as % of merchandise exports) in Nigeria in 1998 and the Imports(as % of merchandise exports) in Spain in 2000?
Offer a very short reply. 10.44. What is the difference between the Imports(as % of merchandise exports) in Nigeria in 1998 and the Imports(as % of merchandise exports) in Zambia in 2000?
Keep it short and to the point. 11.52. What is the difference between the Imports(as % of merchandise exports) in Spain in 1998 and the Imports(as % of merchandise exports) in Zambia in 2000?
Provide a succinct answer. 3.36. What is the difference between the Imports(as % of merchandise exports) of Mali in 1999 and the Imports(as % of merchandise exports) of Nigeria in 2000?
Your answer should be very brief. -0.43. What is the difference between the Imports(as % of merchandise exports) of Mali in 1999 and the Imports(as % of merchandise exports) of Spain in 2000?
Offer a terse response. 10.33. What is the difference between the Imports(as % of merchandise exports) of Mali in 1999 and the Imports(as % of merchandise exports) of Zambia in 2000?
Your response must be concise. 11.41. What is the difference between the Imports(as % of merchandise exports) of Nigeria in 1999 and the Imports(as % of merchandise exports) of Spain in 2000?
Your response must be concise. 17.87. What is the difference between the Imports(as % of merchandise exports) of Nigeria in 1999 and the Imports(as % of merchandise exports) of Zambia in 2000?
Provide a short and direct response. 18.94. What is the difference between the Imports(as % of merchandise exports) in Spain in 1999 and the Imports(as % of merchandise exports) in Zambia in 2000?
Provide a succinct answer. 2.36. What is the average Imports(as % of merchandise exports) of Mali per year?
Your response must be concise. 19.36. What is the average Imports(as % of merchandise exports) of Nigeria per year?
Your response must be concise. 19.06. What is the average Imports(as % of merchandise exports) in Spain per year?
Give a very brief answer. 12.31. What is the average Imports(as % of merchandise exports) of Zambia per year?
Give a very brief answer. 9.43. In the year 1978, what is the difference between the Imports(as % of merchandise exports) of Mali and Imports(as % of merchandise exports) of Nigeria?
Offer a terse response. 8.56. In the year 1978, what is the difference between the Imports(as % of merchandise exports) of Mali and Imports(as % of merchandise exports) of Spain?
Make the answer very short. 6.34. In the year 1978, what is the difference between the Imports(as % of merchandise exports) in Mali and Imports(as % of merchandise exports) in Zambia?
Keep it short and to the point. 14.57. In the year 1978, what is the difference between the Imports(as % of merchandise exports) in Nigeria and Imports(as % of merchandise exports) in Spain?
Offer a very short reply. -2.22. In the year 1978, what is the difference between the Imports(as % of merchandise exports) in Nigeria and Imports(as % of merchandise exports) in Zambia?
Your answer should be compact. 6.01. In the year 1978, what is the difference between the Imports(as % of merchandise exports) in Spain and Imports(as % of merchandise exports) in Zambia?
Ensure brevity in your answer.  8.23. In the year 1979, what is the difference between the Imports(as % of merchandise exports) of Mali and Imports(as % of merchandise exports) of Nigeria?
Your answer should be very brief. -0.71. In the year 1979, what is the difference between the Imports(as % of merchandise exports) of Mali and Imports(as % of merchandise exports) of Spain?
Your answer should be very brief. 1.44. In the year 1979, what is the difference between the Imports(as % of merchandise exports) in Mali and Imports(as % of merchandise exports) in Zambia?
Keep it short and to the point. 7.57. In the year 1979, what is the difference between the Imports(as % of merchandise exports) of Nigeria and Imports(as % of merchandise exports) of Spain?
Offer a terse response. 2.15. In the year 1979, what is the difference between the Imports(as % of merchandise exports) of Nigeria and Imports(as % of merchandise exports) of Zambia?
Your response must be concise. 8.27. In the year 1979, what is the difference between the Imports(as % of merchandise exports) in Spain and Imports(as % of merchandise exports) in Zambia?
Your answer should be very brief. 6.12. In the year 1996, what is the difference between the Imports(as % of merchandise exports) of Mali and Imports(as % of merchandise exports) of Nigeria?
Your answer should be compact. 2.43. In the year 1996, what is the difference between the Imports(as % of merchandise exports) in Mali and Imports(as % of merchandise exports) in Spain?
Your answer should be very brief. 7.61. In the year 1996, what is the difference between the Imports(as % of merchandise exports) in Mali and Imports(as % of merchandise exports) in Zambia?
Provide a short and direct response. 8.97. In the year 1996, what is the difference between the Imports(as % of merchandise exports) in Nigeria and Imports(as % of merchandise exports) in Spain?
Ensure brevity in your answer.  5.18. In the year 1996, what is the difference between the Imports(as % of merchandise exports) in Nigeria and Imports(as % of merchandise exports) in Zambia?
Your answer should be compact. 6.55. In the year 1996, what is the difference between the Imports(as % of merchandise exports) of Spain and Imports(as % of merchandise exports) of Zambia?
Your answer should be compact. 1.36. In the year 1997, what is the difference between the Imports(as % of merchandise exports) in Mali and Imports(as % of merchandise exports) in Nigeria?
Your answer should be very brief. 0.64. In the year 1997, what is the difference between the Imports(as % of merchandise exports) of Mali and Imports(as % of merchandise exports) of Spain?
Ensure brevity in your answer.  7.24. In the year 1997, what is the difference between the Imports(as % of merchandise exports) of Mali and Imports(as % of merchandise exports) of Zambia?
Provide a short and direct response. 10.52. In the year 1997, what is the difference between the Imports(as % of merchandise exports) in Nigeria and Imports(as % of merchandise exports) in Spain?
Make the answer very short. 6.61. In the year 1997, what is the difference between the Imports(as % of merchandise exports) in Nigeria and Imports(as % of merchandise exports) in Zambia?
Give a very brief answer. 9.88. In the year 1997, what is the difference between the Imports(as % of merchandise exports) of Spain and Imports(as % of merchandise exports) of Zambia?
Provide a short and direct response. 3.28. In the year 1998, what is the difference between the Imports(as % of merchandise exports) of Mali and Imports(as % of merchandise exports) of Nigeria?
Make the answer very short. 3.55. In the year 1998, what is the difference between the Imports(as % of merchandise exports) of Mali and Imports(as % of merchandise exports) of Spain?
Your answer should be very brief. 11.71. In the year 1998, what is the difference between the Imports(as % of merchandise exports) of Mali and Imports(as % of merchandise exports) of Zambia?
Provide a succinct answer. 11.39. In the year 1998, what is the difference between the Imports(as % of merchandise exports) in Nigeria and Imports(as % of merchandise exports) in Spain?
Make the answer very short. 8.16. In the year 1998, what is the difference between the Imports(as % of merchandise exports) in Nigeria and Imports(as % of merchandise exports) in Zambia?
Ensure brevity in your answer.  7.85. In the year 1998, what is the difference between the Imports(as % of merchandise exports) in Spain and Imports(as % of merchandise exports) in Zambia?
Give a very brief answer. -0.31. In the year 1999, what is the difference between the Imports(as % of merchandise exports) in Mali and Imports(as % of merchandise exports) in Nigeria?
Provide a succinct answer. -7.53. In the year 1999, what is the difference between the Imports(as % of merchandise exports) in Mali and Imports(as % of merchandise exports) in Spain?
Provide a succinct answer. 9.04. In the year 1999, what is the difference between the Imports(as % of merchandise exports) in Mali and Imports(as % of merchandise exports) in Zambia?
Keep it short and to the point. 9.46. In the year 1999, what is the difference between the Imports(as % of merchandise exports) of Nigeria and Imports(as % of merchandise exports) of Spain?
Provide a succinct answer. 16.58. In the year 1999, what is the difference between the Imports(as % of merchandise exports) of Nigeria and Imports(as % of merchandise exports) of Zambia?
Offer a very short reply. 16.99. In the year 1999, what is the difference between the Imports(as % of merchandise exports) of Spain and Imports(as % of merchandise exports) of Zambia?
Your response must be concise. 0.41. In the year 2000, what is the difference between the Imports(as % of merchandise exports) in Mali and Imports(as % of merchandise exports) in Nigeria?
Give a very brief answer. -4.79. In the year 2000, what is the difference between the Imports(as % of merchandise exports) of Mali and Imports(as % of merchandise exports) of Spain?
Your response must be concise. 5.97. In the year 2000, what is the difference between the Imports(as % of merchandise exports) in Mali and Imports(as % of merchandise exports) in Zambia?
Keep it short and to the point. 7.04. In the year 2000, what is the difference between the Imports(as % of merchandise exports) of Nigeria and Imports(as % of merchandise exports) of Spain?
Keep it short and to the point. 10.76. In the year 2000, what is the difference between the Imports(as % of merchandise exports) in Nigeria and Imports(as % of merchandise exports) in Zambia?
Provide a succinct answer. 11.84. In the year 2000, what is the difference between the Imports(as % of merchandise exports) of Spain and Imports(as % of merchandise exports) of Zambia?
Offer a very short reply. 1.08. What is the ratio of the Imports(as % of merchandise exports) in Mali in 1978 to that in 1979?
Your answer should be compact. 1.41. What is the ratio of the Imports(as % of merchandise exports) of Nigeria in 1978 to that in 1979?
Offer a terse response. 0.84. What is the ratio of the Imports(as % of merchandise exports) in Spain in 1978 to that in 1979?
Make the answer very short. 1.11. What is the ratio of the Imports(as % of merchandise exports) of Zambia in 1978 to that in 1979?
Your response must be concise. 0.95. What is the ratio of the Imports(as % of merchandise exports) of Mali in 1978 to that in 1996?
Offer a very short reply. 1.14. What is the ratio of the Imports(as % of merchandise exports) in Nigeria in 1978 to that in 1996?
Ensure brevity in your answer.  0.81. What is the ratio of the Imports(as % of merchandise exports) of Spain in 1978 to that in 1996?
Provide a short and direct response. 1.33. What is the ratio of the Imports(as % of merchandise exports) in Zambia in 1978 to that in 1996?
Your answer should be compact. 0.74. What is the ratio of the Imports(as % of merchandise exports) of Mali in 1978 to that in 1997?
Offer a terse response. 1.19. What is the ratio of the Imports(as % of merchandise exports) in Nigeria in 1978 to that in 1997?
Your response must be concise. 0.77. What is the ratio of the Imports(as % of merchandise exports) in Spain in 1978 to that in 1997?
Keep it short and to the point. 1.39. What is the ratio of the Imports(as % of merchandise exports) of Zambia in 1978 to that in 1997?
Your response must be concise. 0.95. What is the ratio of the Imports(as % of merchandise exports) of Mali in 1978 to that in 1998?
Offer a very short reply. 0.98. What is the ratio of the Imports(as % of merchandise exports) of Nigeria in 1978 to that in 1998?
Your response must be concise. 0.72. What is the ratio of the Imports(as % of merchandise exports) in Spain in 1978 to that in 1998?
Your answer should be very brief. 1.43. What is the ratio of the Imports(as % of merchandise exports) of Zambia in 1978 to that in 1998?
Make the answer very short. 0.69. What is the ratio of the Imports(as % of merchandise exports) of Mali in 1978 to that in 1999?
Your answer should be very brief. 1.16. What is the ratio of the Imports(as % of merchandise exports) of Nigeria in 1978 to that in 1999?
Your answer should be compact. 0.52. What is the ratio of the Imports(as % of merchandise exports) of Spain in 1978 to that in 1999?
Give a very brief answer. 1.57. What is the ratio of the Imports(as % of merchandise exports) of Zambia in 1978 to that in 1999?
Provide a succinct answer. 0.81. What is the ratio of the Imports(as % of merchandise exports) of Mali in 1978 to that in 2000?
Offer a terse response. 1.5. What is the ratio of the Imports(as % of merchandise exports) in Nigeria in 1978 to that in 2000?
Your answer should be compact. 0.71. What is the ratio of the Imports(as % of merchandise exports) of Spain in 1978 to that in 2000?
Your answer should be compact. 1.79. What is the ratio of the Imports(as % of merchandise exports) of Zambia in 1978 to that in 2000?
Make the answer very short. 1. What is the ratio of the Imports(as % of merchandise exports) of Mali in 1979 to that in 1996?
Offer a terse response. 0.81. What is the ratio of the Imports(as % of merchandise exports) in Nigeria in 1979 to that in 1996?
Give a very brief answer. 0.96. What is the ratio of the Imports(as % of merchandise exports) of Spain in 1979 to that in 1996?
Ensure brevity in your answer.  1.19. What is the ratio of the Imports(as % of merchandise exports) in Zambia in 1979 to that in 1996?
Your response must be concise. 0.78. What is the ratio of the Imports(as % of merchandise exports) in Mali in 1979 to that in 1997?
Provide a succinct answer. 0.85. What is the ratio of the Imports(as % of merchandise exports) in Nigeria in 1979 to that in 1997?
Offer a terse response. 0.92. What is the ratio of the Imports(as % of merchandise exports) of Spain in 1979 to that in 1997?
Ensure brevity in your answer.  1.25. What is the ratio of the Imports(as % of merchandise exports) in Zambia in 1979 to that in 1997?
Make the answer very short. 1.01. What is the ratio of the Imports(as % of merchandise exports) of Mali in 1979 to that in 1998?
Make the answer very short. 0.7. What is the ratio of the Imports(as % of merchandise exports) of Nigeria in 1979 to that in 1998?
Keep it short and to the point. 0.86. What is the ratio of the Imports(as % of merchandise exports) in Spain in 1979 to that in 1998?
Ensure brevity in your answer.  1.29. What is the ratio of the Imports(as % of merchandise exports) of Zambia in 1979 to that in 1998?
Your answer should be very brief. 0.73. What is the ratio of the Imports(as % of merchandise exports) in Mali in 1979 to that in 1999?
Give a very brief answer. 0.83. What is the ratio of the Imports(as % of merchandise exports) of Nigeria in 1979 to that in 1999?
Keep it short and to the point. 0.62. What is the ratio of the Imports(as % of merchandise exports) of Spain in 1979 to that in 1999?
Keep it short and to the point. 1.41. What is the ratio of the Imports(as % of merchandise exports) of Zambia in 1979 to that in 1999?
Provide a short and direct response. 0.85. What is the ratio of the Imports(as % of merchandise exports) of Mali in 1979 to that in 2000?
Provide a succinct answer. 1.07. What is the ratio of the Imports(as % of merchandise exports) in Nigeria in 1979 to that in 2000?
Your answer should be compact. 0.85. What is the ratio of the Imports(as % of merchandise exports) of Spain in 1979 to that in 2000?
Your answer should be compact. 1.61. What is the ratio of the Imports(as % of merchandise exports) of Zambia in 1979 to that in 2000?
Your response must be concise. 1.06. What is the ratio of the Imports(as % of merchandise exports) in Mali in 1996 to that in 1997?
Ensure brevity in your answer.  1.05. What is the ratio of the Imports(as % of merchandise exports) of Nigeria in 1996 to that in 1997?
Provide a short and direct response. 0.95. What is the ratio of the Imports(as % of merchandise exports) in Spain in 1996 to that in 1997?
Make the answer very short. 1.05. What is the ratio of the Imports(as % of merchandise exports) of Zambia in 1996 to that in 1997?
Make the answer very short. 1.29. What is the ratio of the Imports(as % of merchandise exports) in Mali in 1996 to that in 1998?
Your answer should be compact. 0.86. What is the ratio of the Imports(as % of merchandise exports) in Nigeria in 1996 to that in 1998?
Give a very brief answer. 0.89. What is the ratio of the Imports(as % of merchandise exports) in Spain in 1996 to that in 1998?
Ensure brevity in your answer.  1.08. What is the ratio of the Imports(as % of merchandise exports) in Zambia in 1996 to that in 1998?
Provide a short and direct response. 0.93. What is the ratio of the Imports(as % of merchandise exports) of Mali in 1996 to that in 1999?
Offer a terse response. 1.02. What is the ratio of the Imports(as % of merchandise exports) of Nigeria in 1996 to that in 1999?
Your response must be concise. 0.65. What is the ratio of the Imports(as % of merchandise exports) of Spain in 1996 to that in 1999?
Make the answer very short. 1.18. What is the ratio of the Imports(as % of merchandise exports) in Zambia in 1996 to that in 1999?
Make the answer very short. 1.09. What is the ratio of the Imports(as % of merchandise exports) of Mali in 1996 to that in 2000?
Your response must be concise. 1.32. What is the ratio of the Imports(as % of merchandise exports) in Nigeria in 1996 to that in 2000?
Keep it short and to the point. 0.88. What is the ratio of the Imports(as % of merchandise exports) of Spain in 1996 to that in 2000?
Offer a very short reply. 1.35. What is the ratio of the Imports(as % of merchandise exports) of Zambia in 1996 to that in 2000?
Ensure brevity in your answer.  1.36. What is the ratio of the Imports(as % of merchandise exports) of Mali in 1997 to that in 1998?
Your answer should be very brief. 0.82. What is the ratio of the Imports(as % of merchandise exports) of Nigeria in 1997 to that in 1998?
Provide a succinct answer. 0.94. What is the ratio of the Imports(as % of merchandise exports) in Spain in 1997 to that in 1998?
Keep it short and to the point. 1.03. What is the ratio of the Imports(as % of merchandise exports) in Zambia in 1997 to that in 1998?
Provide a short and direct response. 0.72. What is the ratio of the Imports(as % of merchandise exports) in Mali in 1997 to that in 1999?
Make the answer very short. 0.98. What is the ratio of the Imports(as % of merchandise exports) of Nigeria in 1997 to that in 1999?
Your response must be concise. 0.68. What is the ratio of the Imports(as % of merchandise exports) in Spain in 1997 to that in 1999?
Offer a terse response. 1.13. What is the ratio of the Imports(as % of merchandise exports) in Zambia in 1997 to that in 1999?
Make the answer very short. 0.85. What is the ratio of the Imports(as % of merchandise exports) in Mali in 1997 to that in 2000?
Make the answer very short. 1.26. What is the ratio of the Imports(as % of merchandise exports) in Nigeria in 1997 to that in 2000?
Give a very brief answer. 0.92. What is the ratio of the Imports(as % of merchandise exports) in Spain in 1997 to that in 2000?
Give a very brief answer. 1.29. What is the ratio of the Imports(as % of merchandise exports) of Zambia in 1997 to that in 2000?
Your answer should be very brief. 1.05. What is the ratio of the Imports(as % of merchandise exports) of Mali in 1998 to that in 1999?
Your answer should be very brief. 1.19. What is the ratio of the Imports(as % of merchandise exports) of Nigeria in 1998 to that in 1999?
Give a very brief answer. 0.73. What is the ratio of the Imports(as % of merchandise exports) in Spain in 1998 to that in 1999?
Your response must be concise. 1.1. What is the ratio of the Imports(as % of merchandise exports) of Zambia in 1998 to that in 1999?
Your answer should be very brief. 1.17. What is the ratio of the Imports(as % of merchandise exports) in Mali in 1998 to that in 2000?
Offer a terse response. 1.53. What is the ratio of the Imports(as % of merchandise exports) in Nigeria in 1998 to that in 2000?
Offer a terse response. 0.98. What is the ratio of the Imports(as % of merchandise exports) in Spain in 1998 to that in 2000?
Provide a succinct answer. 1.25. What is the ratio of the Imports(as % of merchandise exports) in Zambia in 1998 to that in 2000?
Ensure brevity in your answer.  1.45. What is the ratio of the Imports(as % of merchandise exports) of Mali in 1999 to that in 2000?
Offer a very short reply. 1.29. What is the ratio of the Imports(as % of merchandise exports) in Nigeria in 1999 to that in 2000?
Offer a very short reply. 1.36. What is the ratio of the Imports(as % of merchandise exports) of Spain in 1999 to that in 2000?
Offer a terse response. 1.14. What is the ratio of the Imports(as % of merchandise exports) of Zambia in 1999 to that in 2000?
Provide a succinct answer. 1.24. What is the difference between the highest and the second highest Imports(as % of merchandise exports) in Mali?
Your answer should be compact. 0.45. What is the difference between the highest and the second highest Imports(as % of merchandise exports) of Nigeria?
Keep it short and to the point. 7.1. What is the difference between the highest and the second highest Imports(as % of merchandise exports) in Spain?
Offer a terse response. 1.65. What is the difference between the highest and the second highest Imports(as % of merchandise exports) of Zambia?
Keep it short and to the point. 0.79. What is the difference between the highest and the lowest Imports(as % of merchandise exports) in Mali?
Your answer should be very brief. 8.02. What is the difference between the highest and the lowest Imports(as % of merchandise exports) in Nigeria?
Your answer should be very brief. 12.89. What is the difference between the highest and the lowest Imports(as % of merchandise exports) in Spain?
Provide a short and direct response. 7.19. What is the difference between the highest and the lowest Imports(as % of merchandise exports) of Zambia?
Make the answer very short. 3.67. 